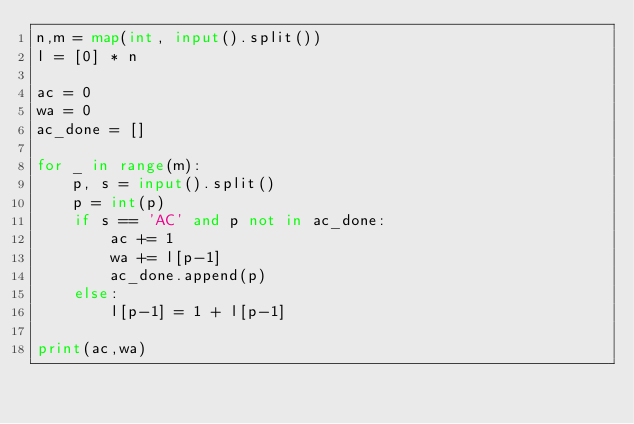<code> <loc_0><loc_0><loc_500><loc_500><_Python_>n,m = map(int, input().split())
l = [0] * n

ac = 0
wa = 0
ac_done = []

for _ in range(m):
    p, s = input().split()
    p = int(p)
    if s == 'AC' and p not in ac_done:
        ac += 1
        wa += l[p-1]
        ac_done.append(p)
    else:
        l[p-1] = 1 + l[p-1]

print(ac,wa)</code> 